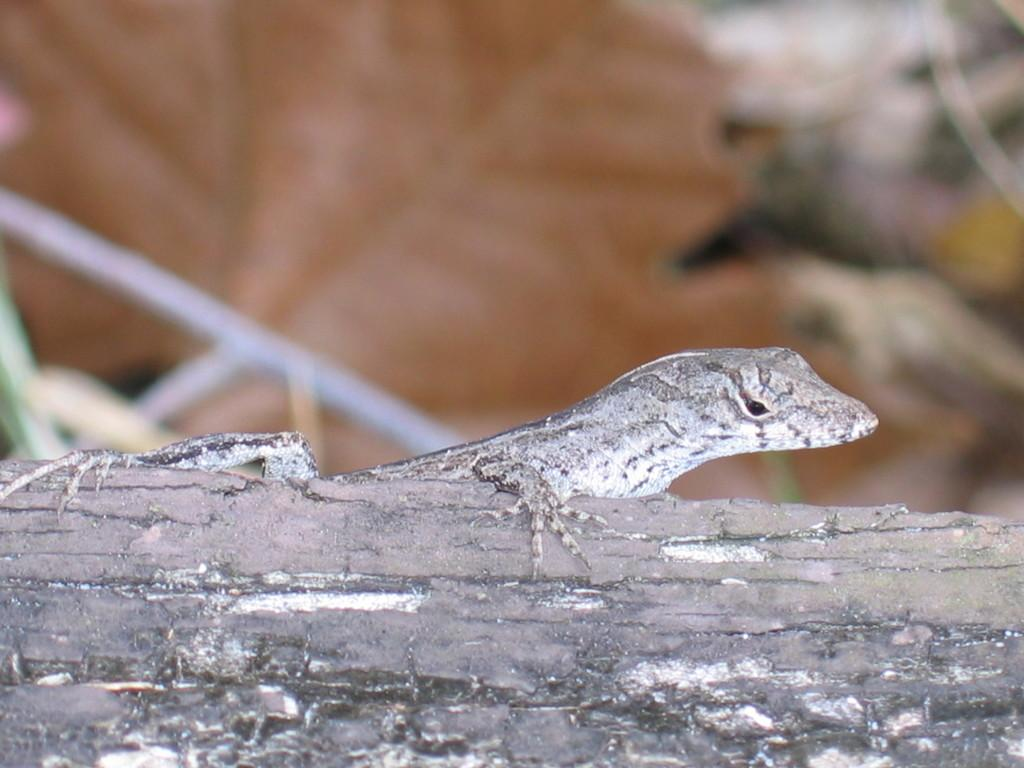What type of animal is in the image? There is a lizard in the image. Where is the lizard located? The lizard is on a piece of wood. What can be seen in the background of the image? There are brown-colored leaves visible in the background. What type of silk is being produced by the volcano in the image? There is no volcano or silk present in the image; it features a lizard on a piece of wood with brown-colored leaves in the background. 